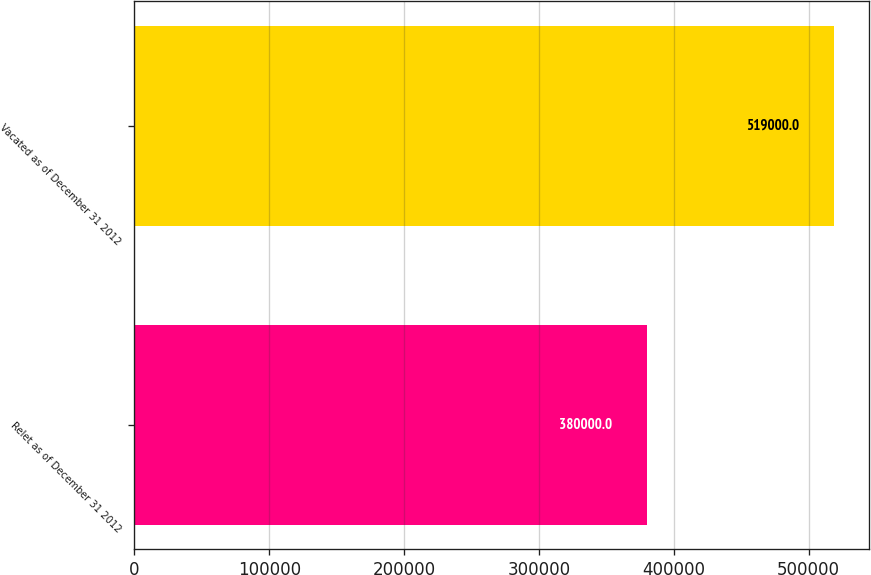<chart> <loc_0><loc_0><loc_500><loc_500><bar_chart><fcel>Relet as of December 31 2012<fcel>Vacated as of December 31 2012<nl><fcel>380000<fcel>519000<nl></chart> 